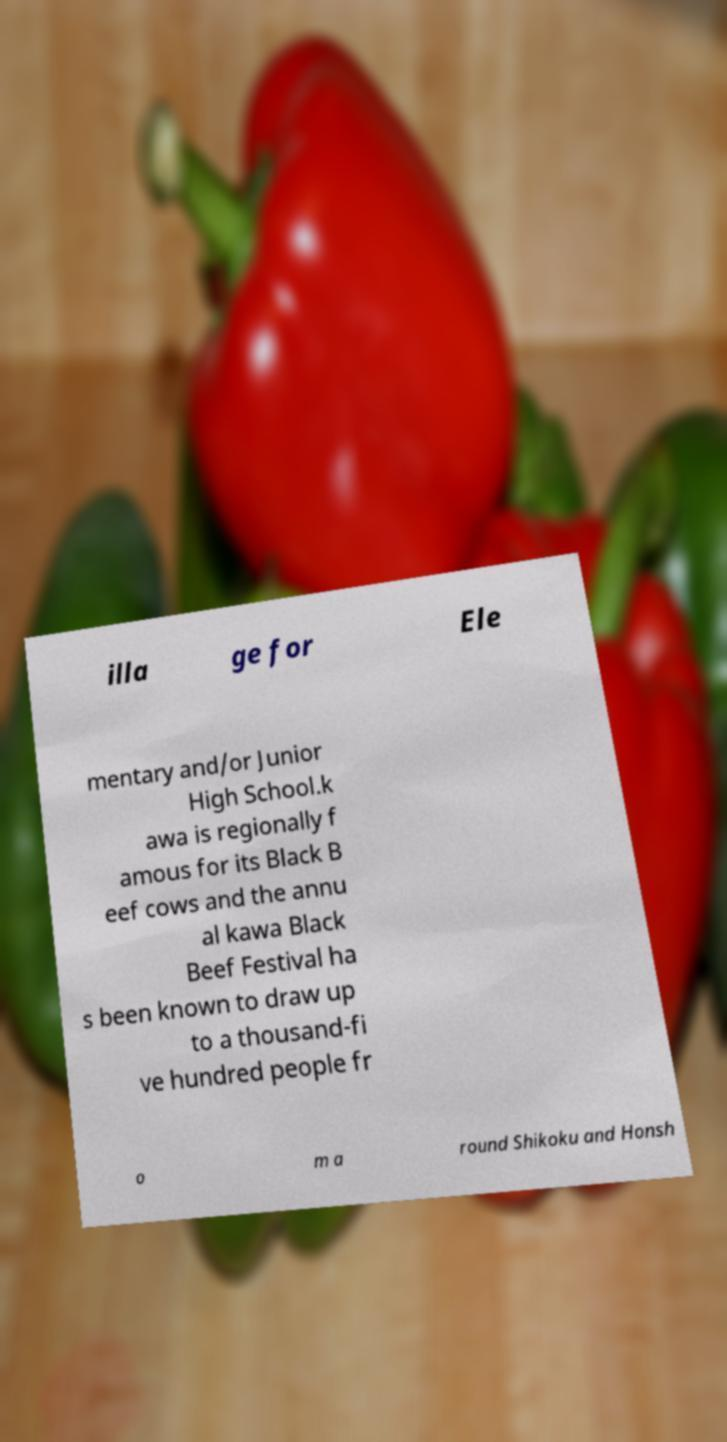Can you read and provide the text displayed in the image?This photo seems to have some interesting text. Can you extract and type it out for me? illa ge for Ele mentary and/or Junior High School.k awa is regionally f amous for its Black B eef cows and the annu al kawa Black Beef Festival ha s been known to draw up to a thousand-fi ve hundred people fr o m a round Shikoku and Honsh 